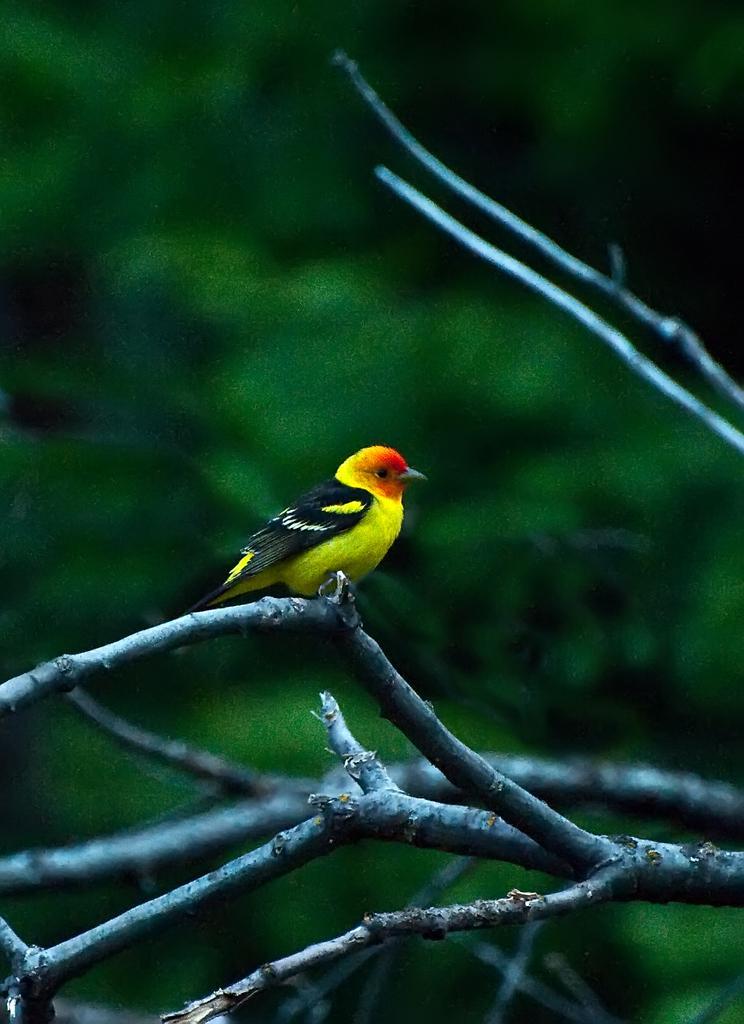How would you summarize this image in a sentence or two? In this picture there is a bird in the center of the image, on a branch. 